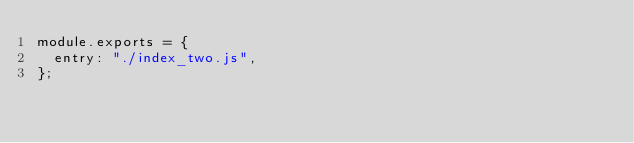<code> <loc_0><loc_0><loc_500><loc_500><_JavaScript_>module.exports = {
  entry: "./index_two.js",
};
</code> 